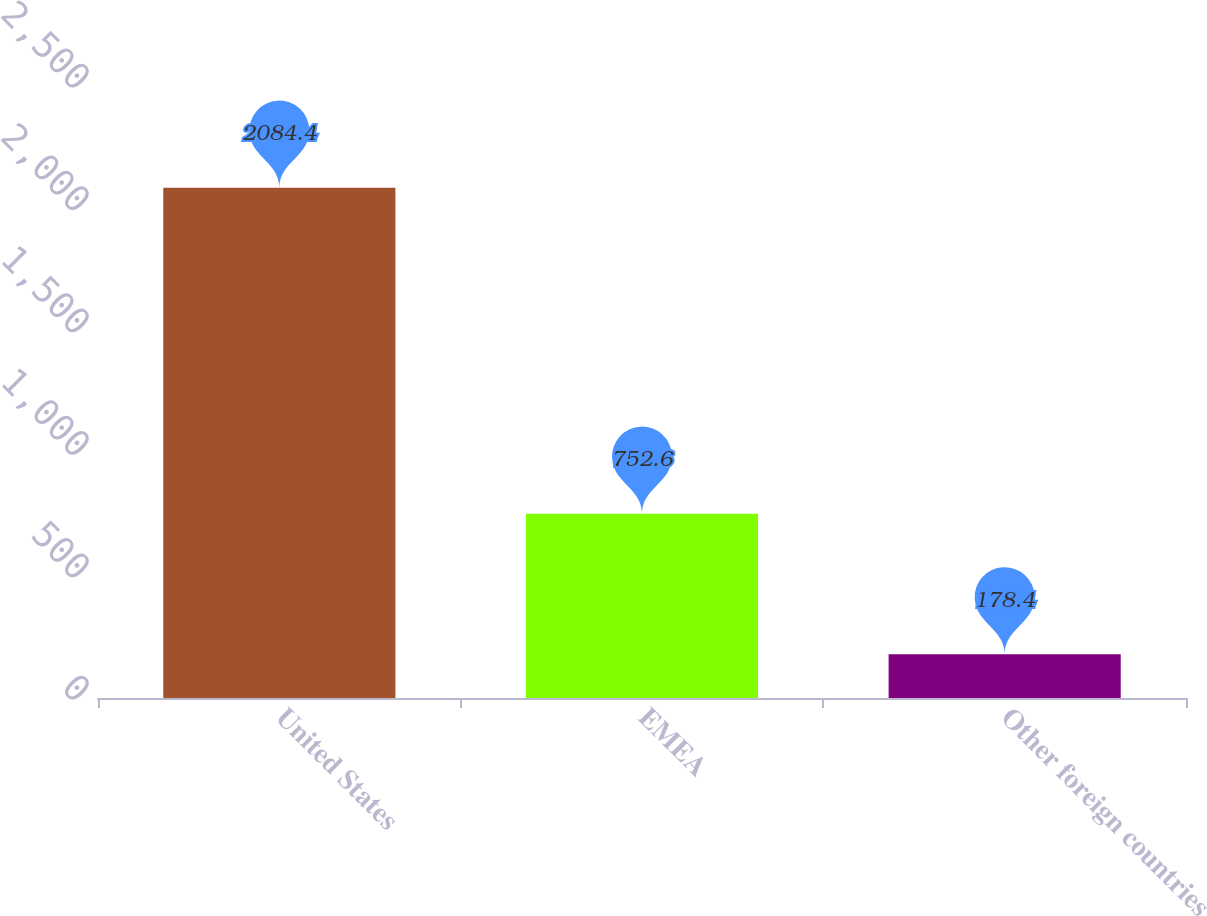Convert chart to OTSL. <chart><loc_0><loc_0><loc_500><loc_500><bar_chart><fcel>United States<fcel>EMEA<fcel>Other foreign countries<nl><fcel>2084.4<fcel>752.6<fcel>178.4<nl></chart> 